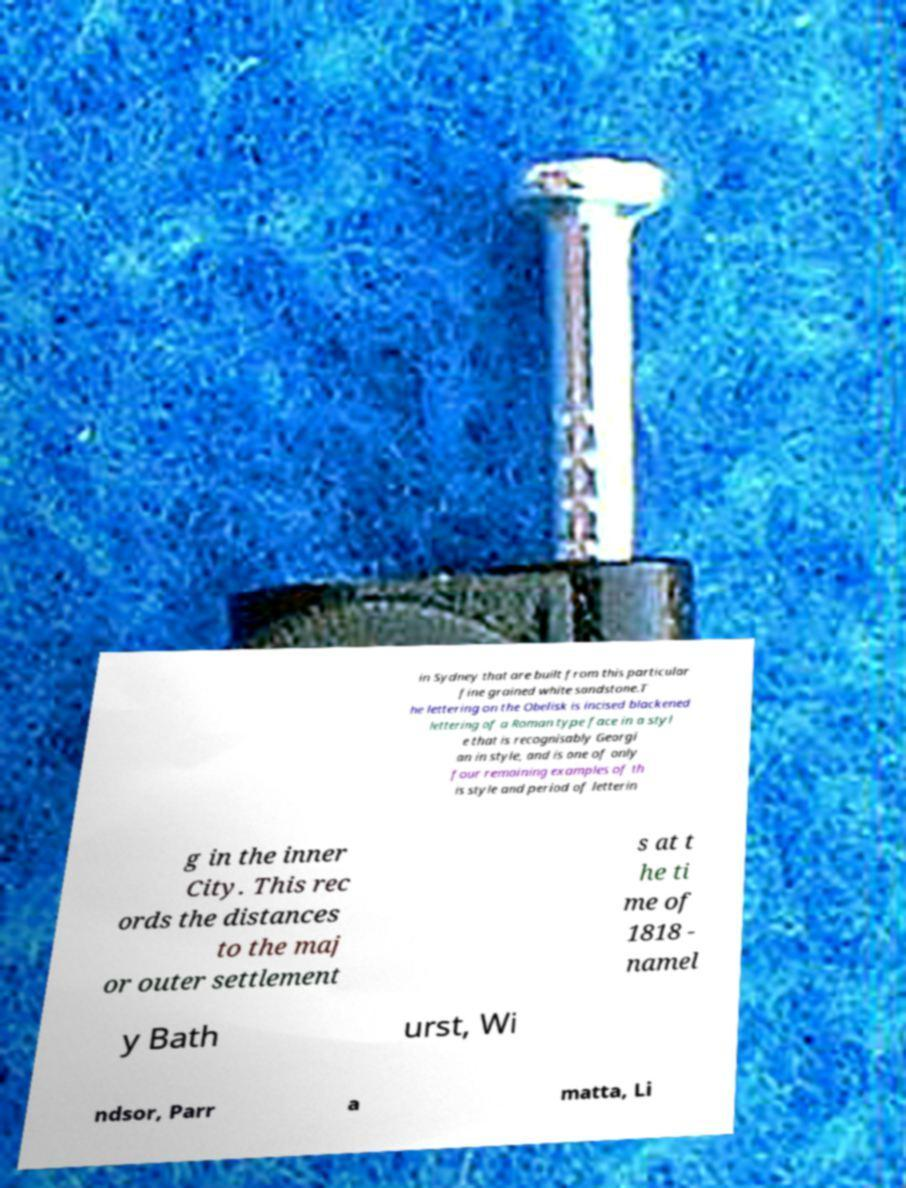Can you accurately transcribe the text from the provided image for me? in Sydney that are built from this particular fine grained white sandstone.T he lettering on the Obelisk is incised blackened lettering of a Roman type face in a styl e that is recognisably Georgi an in style, and is one of only four remaining examples of th is style and period of letterin g in the inner City. This rec ords the distances to the maj or outer settlement s at t he ti me of 1818 - namel y Bath urst, Wi ndsor, Parr a matta, Li 